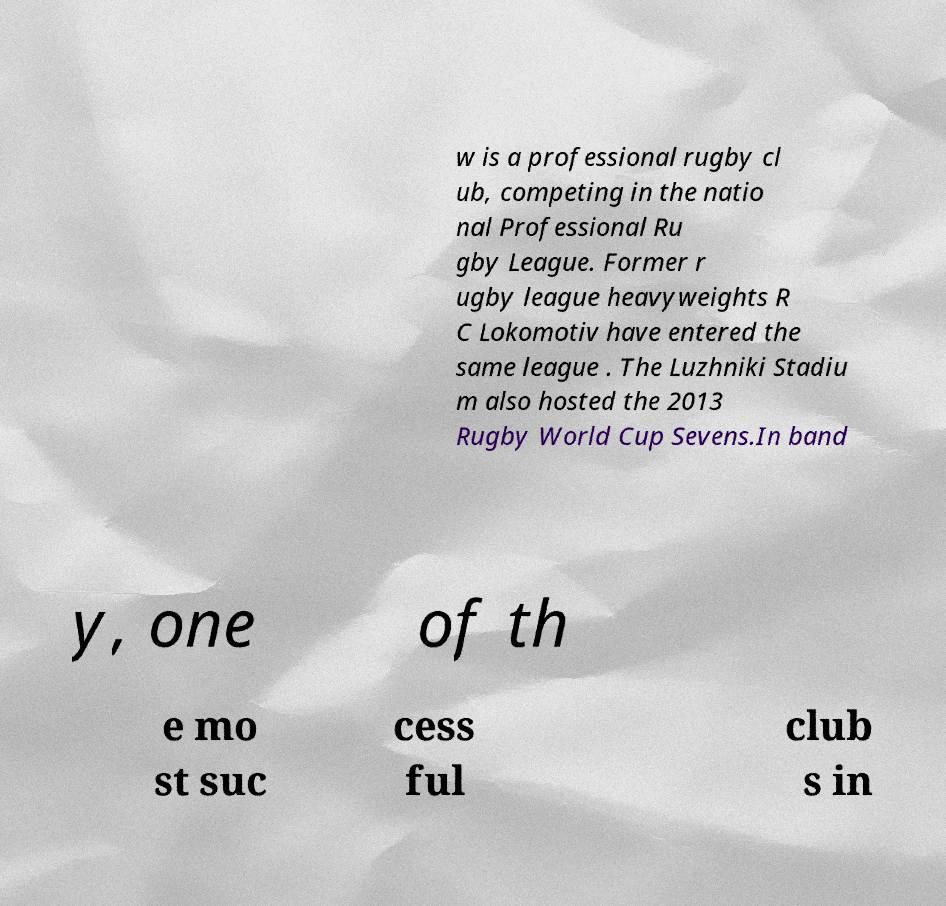For documentation purposes, I need the text within this image transcribed. Could you provide that? w is a professional rugby cl ub, competing in the natio nal Professional Ru gby League. Former r ugby league heavyweights R C Lokomotiv have entered the same league . The Luzhniki Stadiu m also hosted the 2013 Rugby World Cup Sevens.In band y, one of th e mo st suc cess ful club s in 